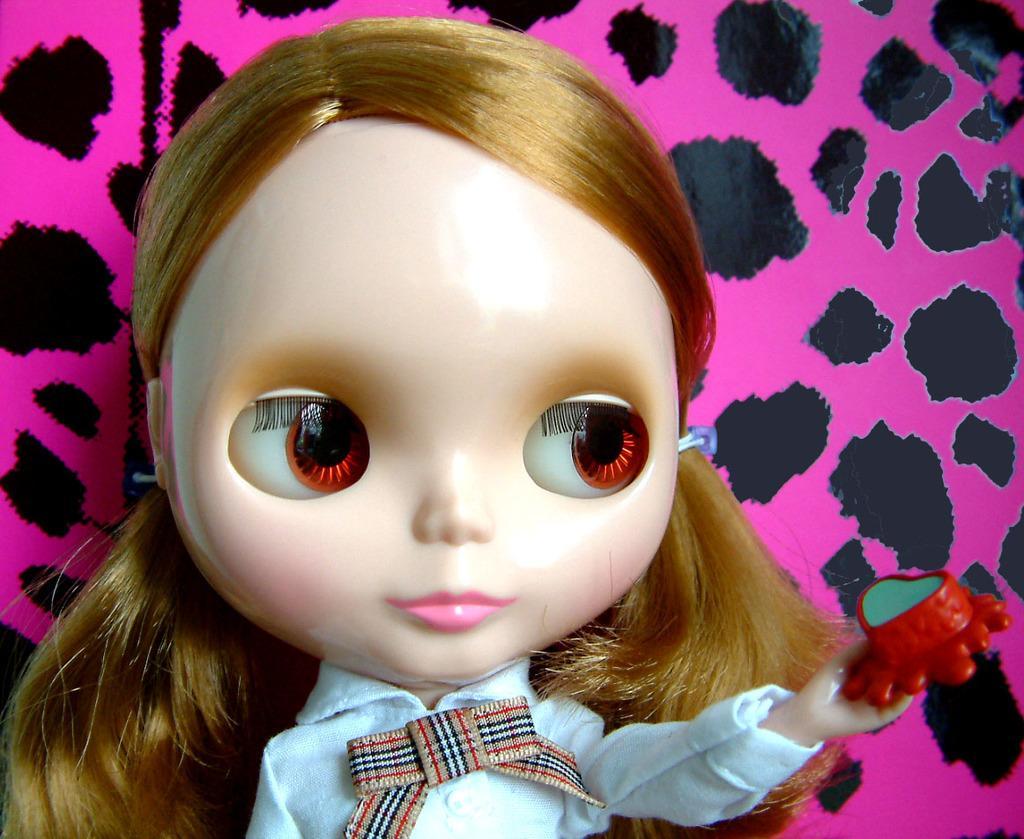Can you describe this image briefly? In the picture I can see the toy of a girl, behind we can see colorful thing. 